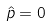<formula> <loc_0><loc_0><loc_500><loc_500>\hat { p } = 0</formula> 